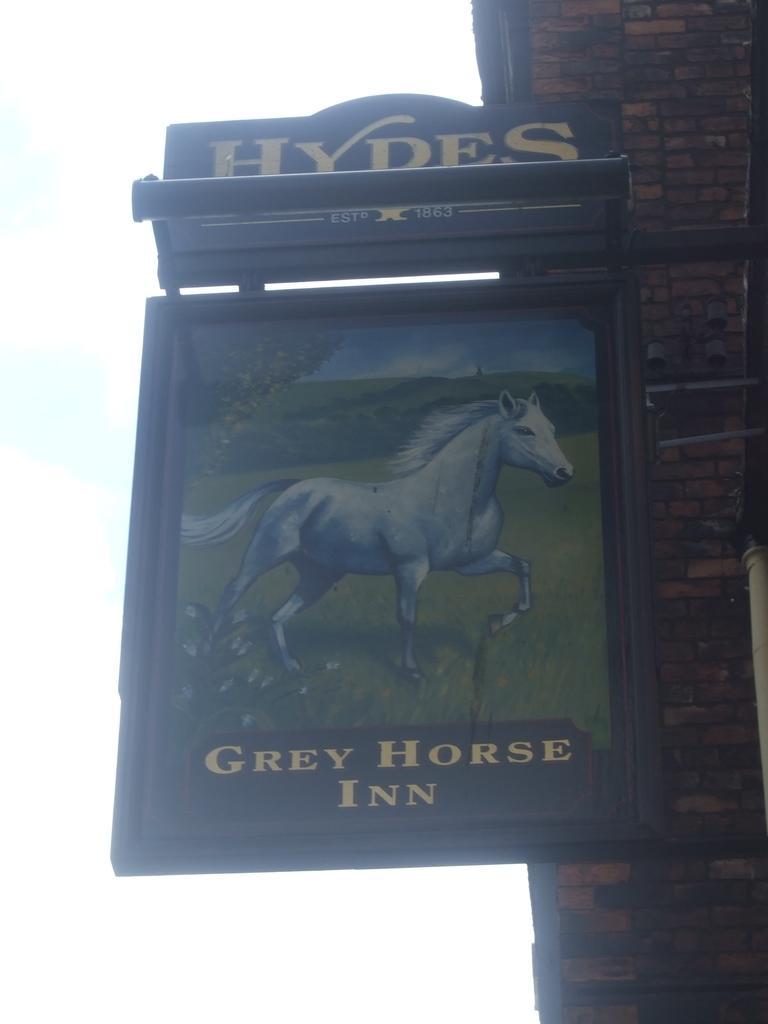Describe this image in one or two sentences. In this image I can see the board attached to the wall and I can see the horse in the board. In the background I can see the sky in white color. 